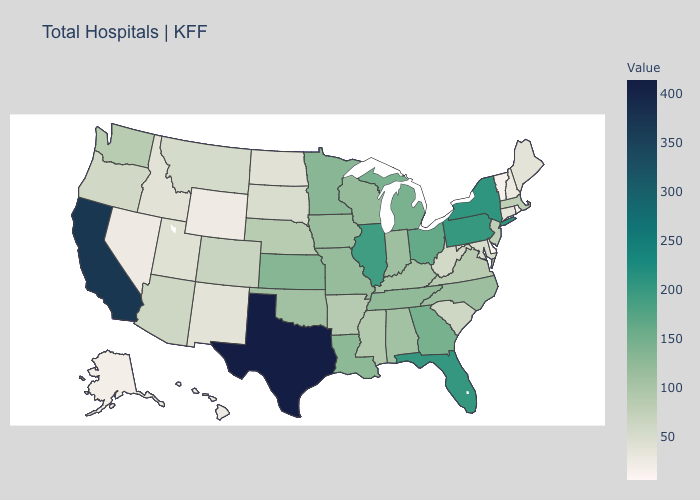Does Texas have the highest value in the South?
Give a very brief answer. Yes. Among the states that border Florida , does Alabama have the lowest value?
Concise answer only. Yes. Which states have the highest value in the USA?
Write a very short answer. Texas. Among the states that border Missouri , does Arkansas have the lowest value?
Quick response, please. No. 